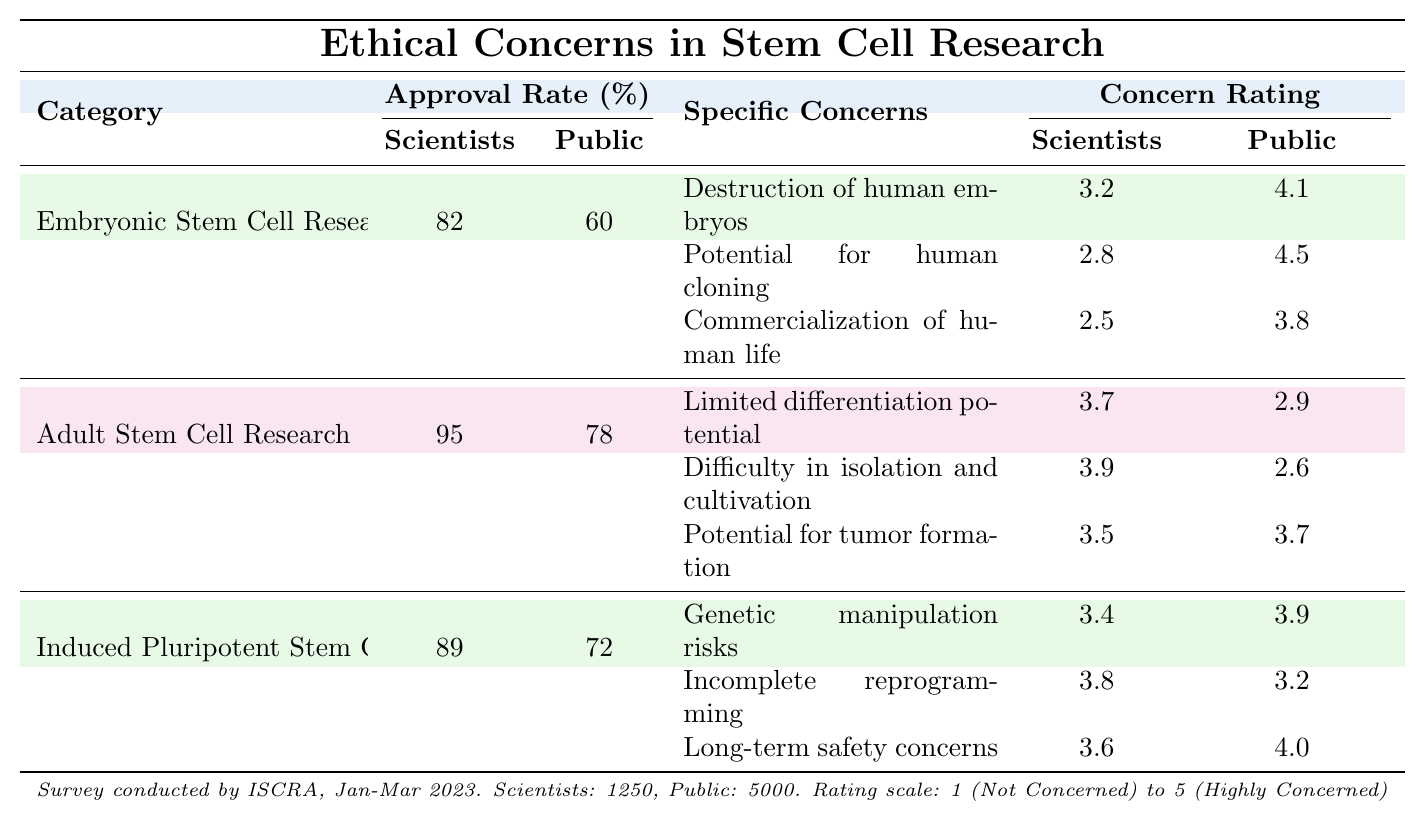What is the approval rate for embryonic stem cell research among scientists? The approval rate for embryonic stem cell research is listed under the "Scientists' Approval Rate" column in the table, which shows a value of 82%.
Answer: 82% What is the public approval rate for adult stem cell research? The public approval rate for adult stem cell research can be found in the "Public Approval Rate" column, which indicates a rate of 78%.
Answer: 78% Which category of stem cell research has the highest approval rate from scientists? The highest approval rate from scientists is for adult stem cell research, which has a rate of 95%, as stated in the "Scientists' Approval Rate" column.
Answer: Adult Stem Cell Research What is the average concern rating for the specific concerns listed under embryonic stem cell research? The concern ratings for embryonic stem cell research are 3.2, 2.8, and 2.5. To find the average, sum these values (3.2 + 2.8 + 2.5 = 8.5) and divide by 3 (8.5 / 3 ≈ 2.83).
Answer: 2.83 Which specific concern about adult stem cell research has the lowest public concern rating? The lowest public concern rating for adult stem cell research is for "Difficulty in isolation and cultivation," which has a public rating of 2.6. This can be confirmed by comparing the ratings listed under the "Concern Rating" section for public ratings.
Answer: Difficulty in isolation and cultivation Is the public concern rating for "Potential for human cloning" greater than the rating for "Destruction of human embryos"? Yes, the public concern rating for "Potential for human cloning" is 4.5, while the rating for "Destruction of human embryos" is 4.1, confirming the statement by comparing the two values directly from the table.
Answer: Yes What is the difference in approval rates between scientists and the public for induced pluripotent stem cell research? The approval rate for scientists is 89%, while for the public it is 72%. The difference is calculated by subtracting the public rate from the scientist rate (89 - 72 = 17).
Answer: 17% What is the highest concern rating for any specific concern listed in the table, regardless of research category? The highest concern rating across all categories is 4.5, linked to the public's concern over "Potential for human cloning". This can be determined by reviewing each specific concern’s public ratings and identifying the maximum value.
Answer: 4.5 What percentage of scientists approve of embryonic stem cell research compared to adult stem cell research? The percentage of scientists approving embryonic stem cell research is 82%, compared with 95% for adult stem cell research. To find the difference, we subtract the two approval rates (95 - 82 = 13%).
Answer: 13% What is the overall public approval rate for all three research categories combined? To find the overall public approval rate, we add the public approval rates for all three categories (60 + 78 + 72 = 210) and then divide by the number of categories (210 / 3 = 70).
Answer: 70 